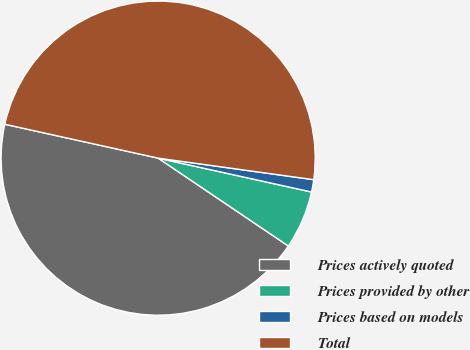<chart> <loc_0><loc_0><loc_500><loc_500><pie_chart><fcel>Prices actively quoted<fcel>Prices provided by other<fcel>Prices based on models<fcel>Total<nl><fcel>44.01%<fcel>5.99%<fcel>1.27%<fcel>48.73%<nl></chart> 